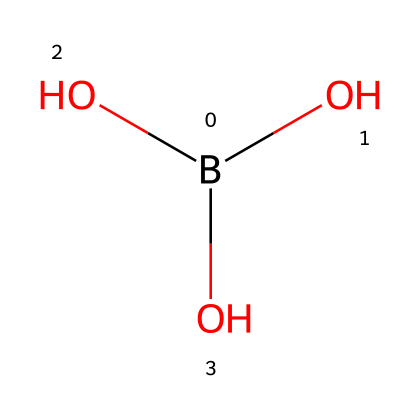What is the name of this chemical? The chemical structure represents boric acid, which is a common acid used for various applications, including flame retardants. The presence of the boron atom and the three hydroxyl groups indicates this specific compound.
Answer: boric acid How many oxygen atoms are present in this chemical? By analyzing the structure, we observe three hydroxyl groups, each containing one oxygen atom. Therefore, there are three oxygen atoms in total.
Answer: three What is the chemical classification of boric acid? Boric acid is classified as a weak acid due to its ability to partially dissociate in solution, which is indicated by its structure containing boron and hydroxyl groups.
Answer: weak acid How many hydrogen atoms can be found in this chemical? The structure consists of three hydroxyl groups (each contributes one hydrogen atom) and one additional hydrogen from the boron. Thus, there are four hydrogen atoms in total.
Answer: four What role do the hydroxyl groups play in this acid? The hydroxyl groups (-OH) allow for hydrogen bonding and contribute to the acidic properties of boric acid by facilitating the release of hydrogen ions (H+) in aqueous solutions.
Answer: acidic properties What is the primary use of boric acid in military applications? Boric acid is primarily used as a flame retardant in military uniforms, helping to reduce flammability and enhance safety during operations.
Answer: flame retardant 